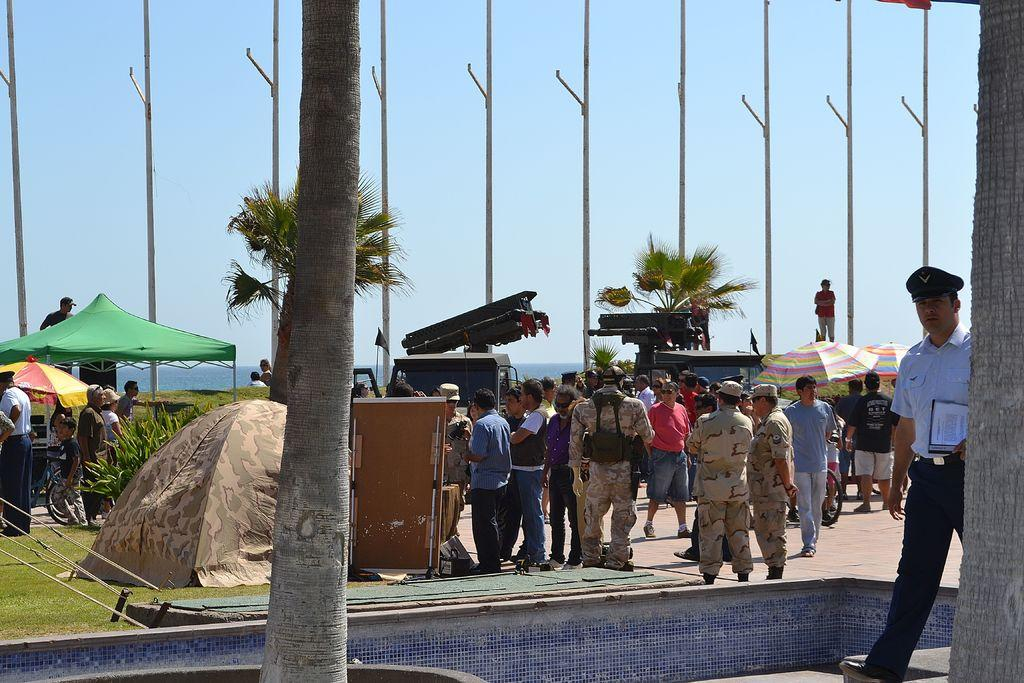What are the people in the image doing? The people in the image are standing on a pavement. What can be seen in the background of the image? In the background of the image, there are tents, poles, trees, and the sky. Can you describe the setting of the image? The people are standing on a pavement, and there are tents, poles, trees, and the sky visible in the background. What type of oatmeal is being served in the image? There is no oatmeal present in the image. What belief system do the people in the image follow? There is no information about the people's beliefs in the image. 